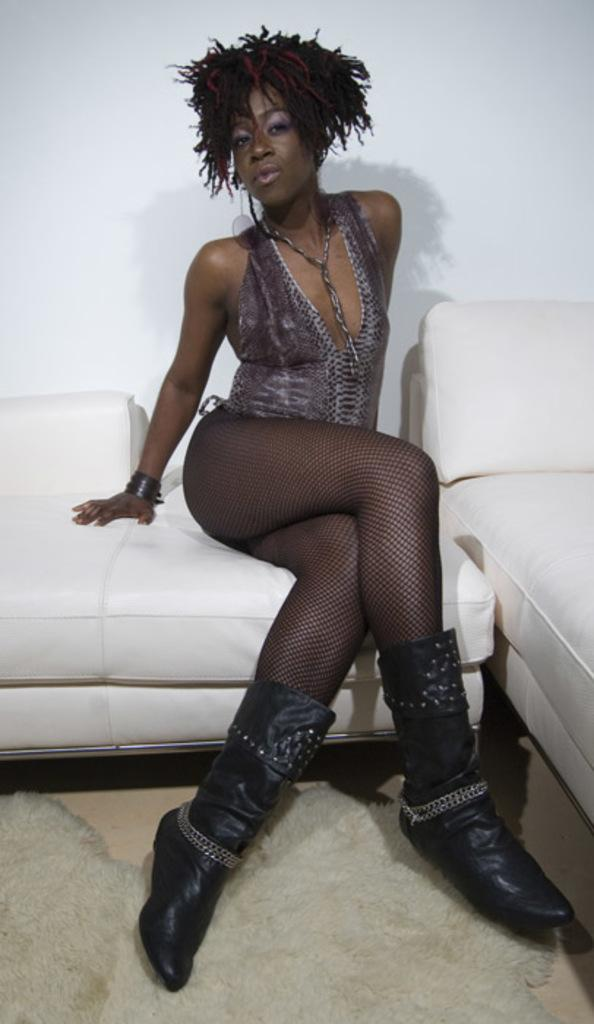How many couches are present in the image? There are two couches in the image. What color is the wall in the image? The wall in the image is white. What is the lady in the image doing? The lady is sitting on one of the couches. What is on the floor in the image? There is a mat on the floor in the image. Can you see a ghost sitting on the other couch in the image? No, there is no ghost present in the image. What is the reason for the lady sitting on the couch in the image? The image does not provide any information about the reason for the lady sitting on the couch. 